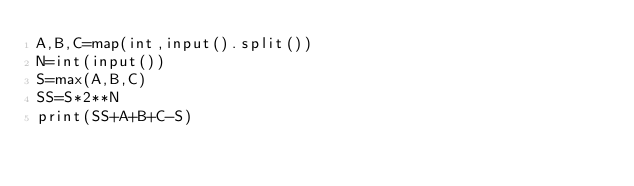<code> <loc_0><loc_0><loc_500><loc_500><_Python_>A,B,C=map(int,input().split())
N=int(input())
S=max(A,B,C)
SS=S*2**N
print(SS+A+B+C-S)</code> 